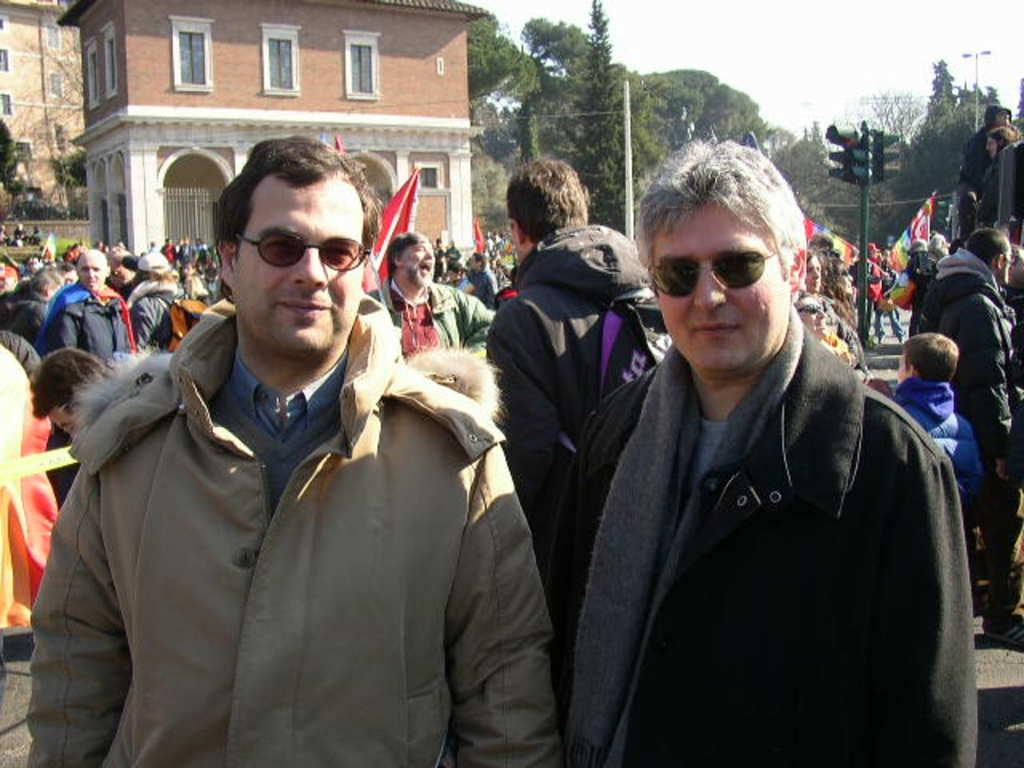Who or what can be seen in the image? There are people in the image. What is the purpose of the object with red, yellow, and green lights in the image? There is a traffic signal in the image, which is used to control the flow of traffic. What type of structures are visible in the image? There are buildings in the image. What is the source of light visible on the street in the image? There is a streetlight in the image. What can be seen in the distance in the image? There are trees in the background of the image. Reasoning: Let's think step by step by step in order to produce the conversation. We start by identifying the main subjects in the image, which are the people. Then, we expand the conversation to include other objects and structures that are also visible, such as the traffic signal, buildings, streetlight, and trees. Each question is designed to elicit a specific detail about the image that is known from the provided facts. Absurd Question/Answer: What type of board is being used by the people in the image? There is no board visible in the image; the people are not using any board. What color is the orange in the image? There is no orange present in the image. 